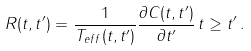Convert formula to latex. <formula><loc_0><loc_0><loc_500><loc_500>R ( t , t ^ { \prime } ) = \frac { 1 } { T _ { { e f f } } ( t , t ^ { \prime } ) } \frac { \partial C ( t , t ^ { \prime } ) } { \partial t ^ { \prime } } \, t \geq t ^ { \prime } \, .</formula> 